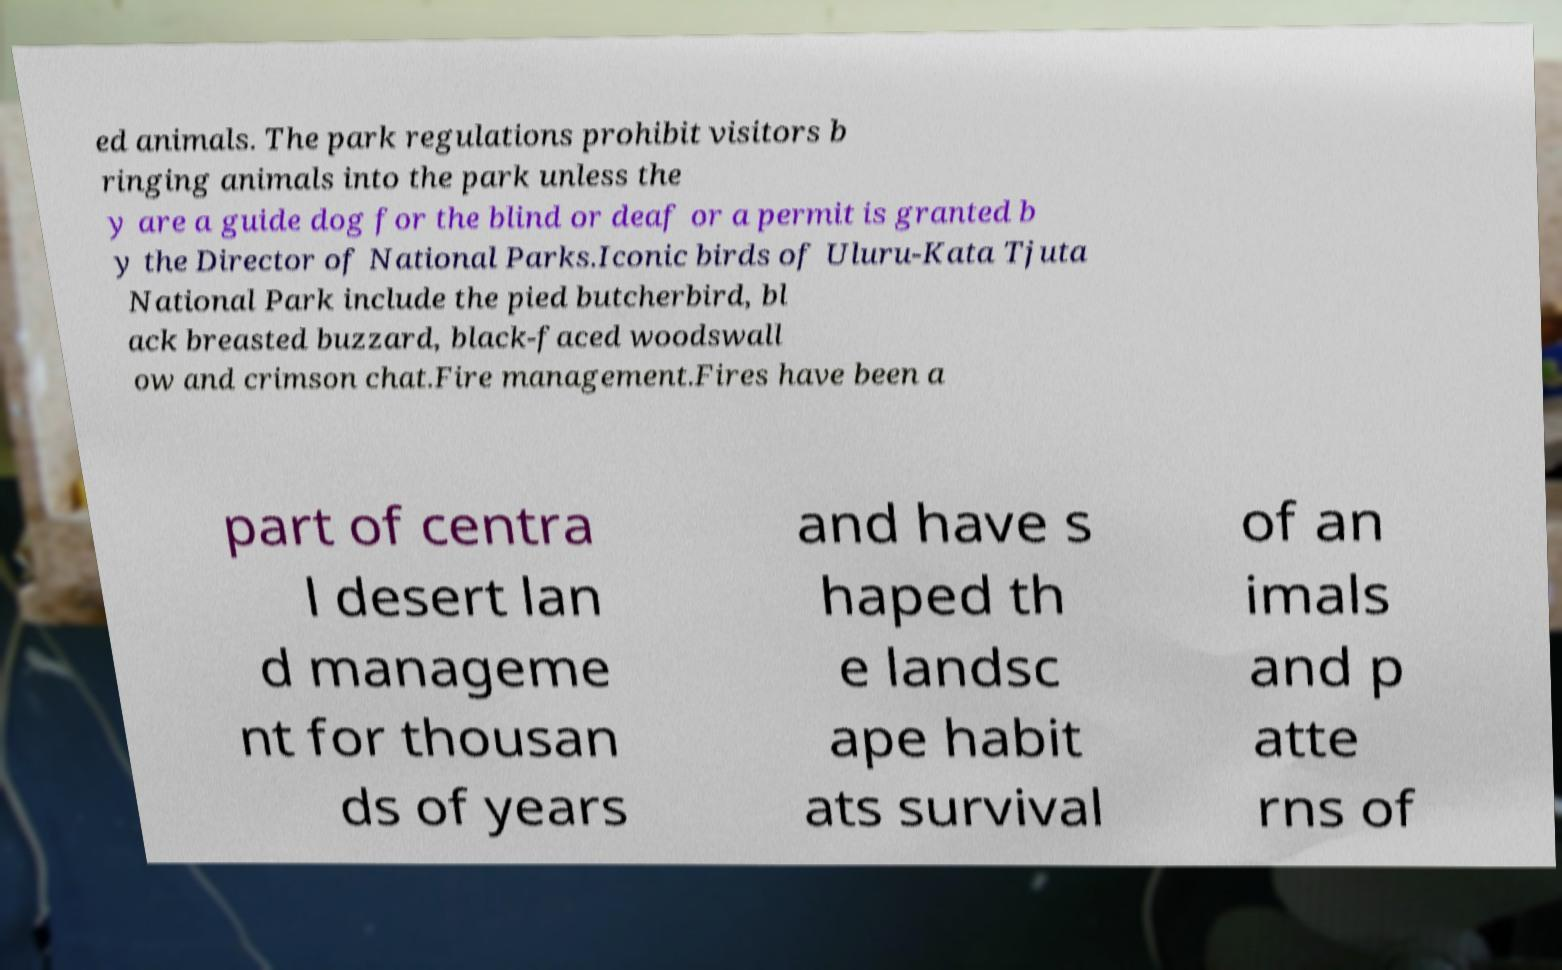What messages or text are displayed in this image? I need them in a readable, typed format. ed animals. The park regulations prohibit visitors b ringing animals into the park unless the y are a guide dog for the blind or deaf or a permit is granted b y the Director of National Parks.Iconic birds of Uluru-Kata Tjuta National Park include the pied butcherbird, bl ack breasted buzzard, black-faced woodswall ow and crimson chat.Fire management.Fires have been a part of centra l desert lan d manageme nt for thousan ds of years and have s haped th e landsc ape habit ats survival of an imals and p atte rns of 